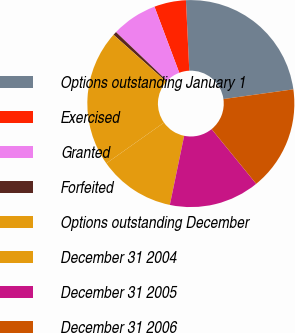Convert chart. <chart><loc_0><loc_0><loc_500><loc_500><pie_chart><fcel>Options outstanding January 1<fcel>Exercised<fcel>Granted<fcel>Forfeited<fcel>Options outstanding December<fcel>December 31 2004<fcel>December 31 2005<fcel>December 31 2006<nl><fcel>23.56%<fcel>4.96%<fcel>7.15%<fcel>0.56%<fcel>21.37%<fcel>11.95%<fcel>14.13%<fcel>16.32%<nl></chart> 